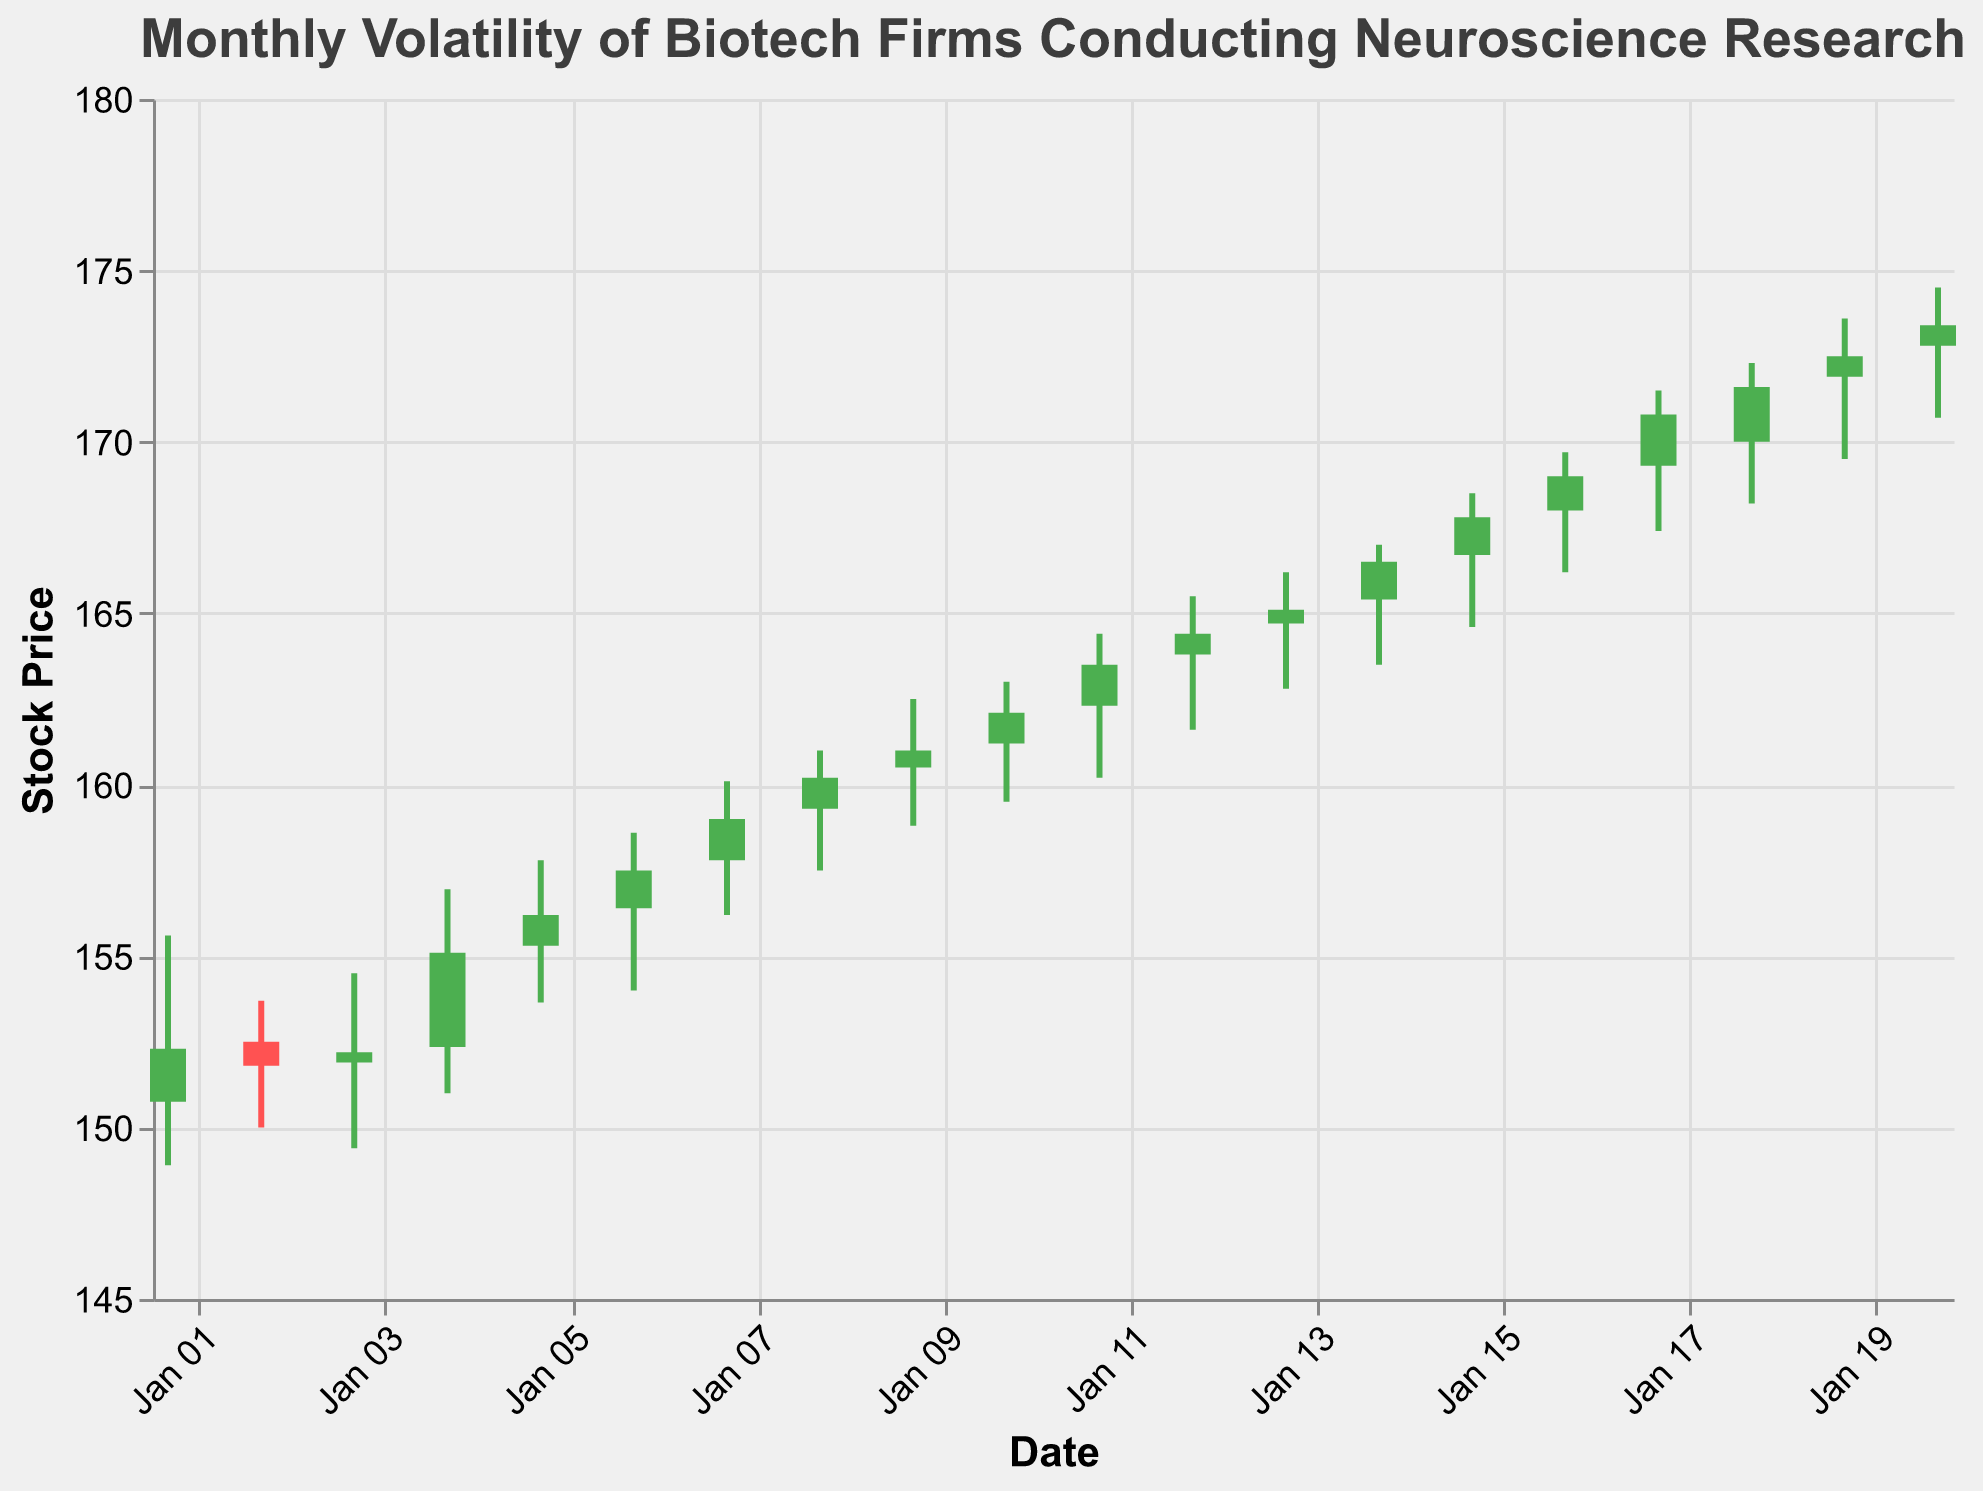What is the title of the figure? The title is usually displayed at the top of the figure, written in clear and large font. Here it is "Monthly Volatility of Biotech Firms Conducting Neuroscience Research"
Answer: Monthly Volatility of Biotech Firms Conducting Neuroscience Research What date has the highest stock price? To find the highest stock price, we look for the highest point on the `High` aspect of the candlestick plot. The highest point is on January 20th at 174.50
Answer: January 20th On which date did the stock have the lowest closing price? By looking at the `Close` values, we compare each day's closing price. The lowest closing price is 151.80 on January 2nd
Answer: January 2nd How many days in January did the stock price increase? We compare the `Open` and `Close` values for each day. A stock price increase means `Close` is higher than `Open`. There are 14 days where this condition is met
Answer: 14 days On what date does the largest difference between the high and low price occur? Calculate the difference between `High` and `Low` for each date and find the maximum difference. The largest difference is 5.95 on January 4th
Answer: January 4th What is the average closing price for the first week of January? Sum the closing prices from January 1st to January 7th and divide by 7: (152.30 + 151.80 + 152.20 + 155.10 + 156.20 + 157.50 + 159.00) / 7 = 154.87 (approximately)
Answer: 154.87 (approximately) Which day had the smallest trading range (high minus low)? Calculate the trading range (High - Low) for each day and find the minimum value. The smallest range is 1.60 on January 2nd
Answer: January 2nd On how many days did the stock close lower than it opened? Count the days where `Close` is less than `Open`. There are 5 days where this is true
Answer: 5 days What is the trend of the stock price from January 15th to January 20th? Compare `Close` values from January 15th to January 20th, noting the increasing pattern. The closing prices are 167.80, 169.00, 170.80, 171.60, 172.50, and 173.40. This shows an upward trend
Answer: Upward Trend How much did the stock price grow in total from January 1st to January 20th? Subtract the closing price on January 1st from the closing price on January 20th. 173.40 (Jan 20) - 152.30 (Jan 1) = 21.10
Answer: 21.10 